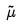Convert formula to latex. <formula><loc_0><loc_0><loc_500><loc_500>\tilde { \mu }</formula> 